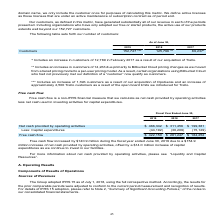According to Atlassian Plc's financial document, How is free cash flow calculated? Net cash provided by operating activities less net cash used in investing activities for capital expenditures.. The document states: "a non-IFRS financial measure that we calculate as net cash provided by operating activities less net cash used in investing activities for capital exp..." Also, What was the increase in free cash flow between fiscal year 2018 and 2019? According to the financial document, $140.9 million. The relevant text states: "Free cash flow increased by $140.9 million during the fiscal year ended June 30, 2019 due to a $154.9..." Also, What is the amount of free cash flow in 2019? According to the financial document, $422,150 (in thousands). The relevant text states: "Free cash flow $ 422,150 $ 281,247 $ 184,252..." Also, can you calculate: What is the average net cash provided by operating activities from 2017-2019? To answer this question, I need to perform calculations using the financial data. The calculation is: (466,342+311,456+199,381)/3, which equals 325726.33 (in thousands). This is based on the information: "Net cash provided by operating activities $ 466,342 $ 311,456 $ 199,381 ded by operating activities $ 466,342 $ 311,456 $ 199,381 cash provided by operating activities $ 466,342 $ 311,456 $ 199,381..." The key data points involved are: 199,381, 311,456, 466,342. Also, can you calculate: What is the percentage change in free cash flow between 2017 and 2018? To answer this question, I need to perform calculations using the financial data. The calculation is: (281,247-184,252)/184,252, which equals 52.64 (percentage). This is based on the information: "Free cash flow $ 422,150 $ 281,247 $ 184,252 Free cash flow $ 422,150 $ 281,247 $ 184,252..." The key data points involved are: 184,252, 281,247. Also, can you calculate: What is the change in capital expenditures between 2018 and 2019? Based on the calculation: -44,192-(-30,209), the result is -13983 (in thousands). This is based on the information: "Less: Capital expenditures (44,192) (30,209) (15,129) Less: Capital expenditures (44,192) (30,209) (15,129)..." The key data points involved are: 30,209, 44,192. 